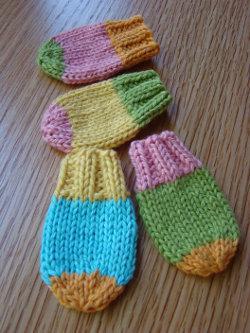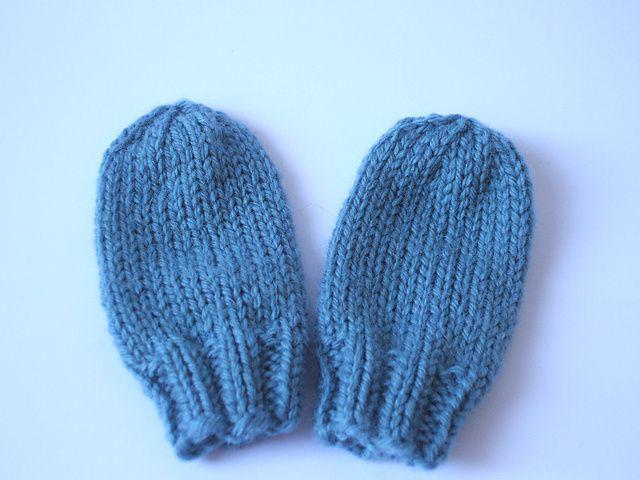The first image is the image on the left, the second image is the image on the right. Given the left and right images, does the statement "One image shows at least one knitted mitten modelled on a human hand." hold true? Answer yes or no. No. The first image is the image on the left, the second image is the image on the right. Examine the images to the left and right. Is the description "The right image contains at least two mittens." accurate? Answer yes or no. Yes. 